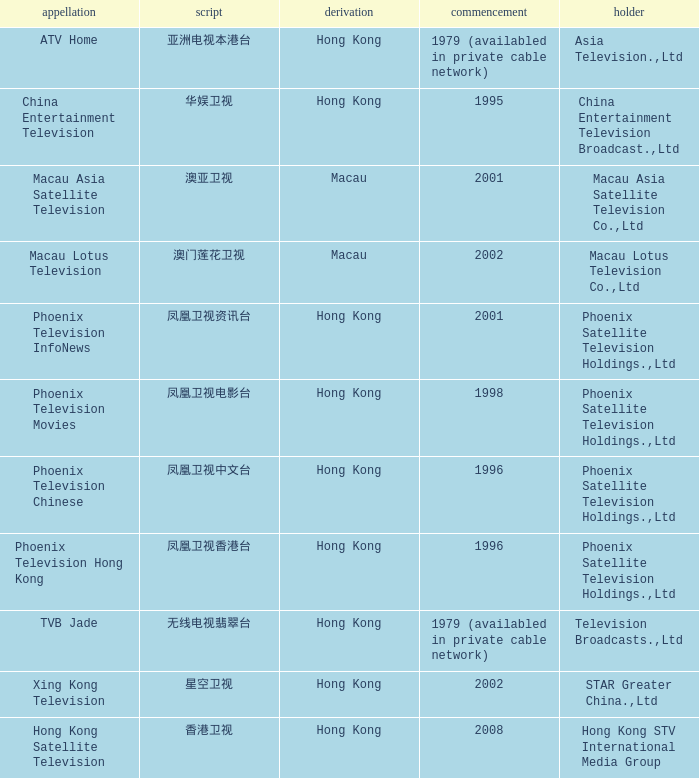Where did the Hanzi of 凤凰卫视电影台 originate? Hong Kong. 